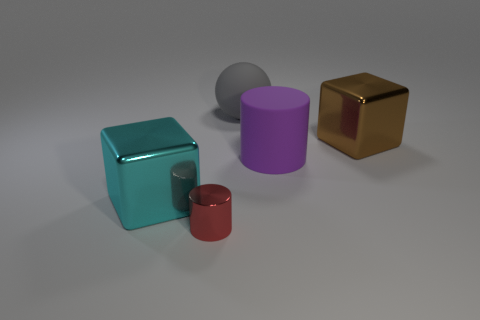Add 4 tiny brown cubes. How many objects exist? 9 Subtract all cubes. How many objects are left? 3 Subtract all small red things. Subtract all red metallic objects. How many objects are left? 3 Add 2 purple things. How many purple things are left? 3 Add 1 tiny cylinders. How many tiny cylinders exist? 2 Subtract 0 yellow cubes. How many objects are left? 5 